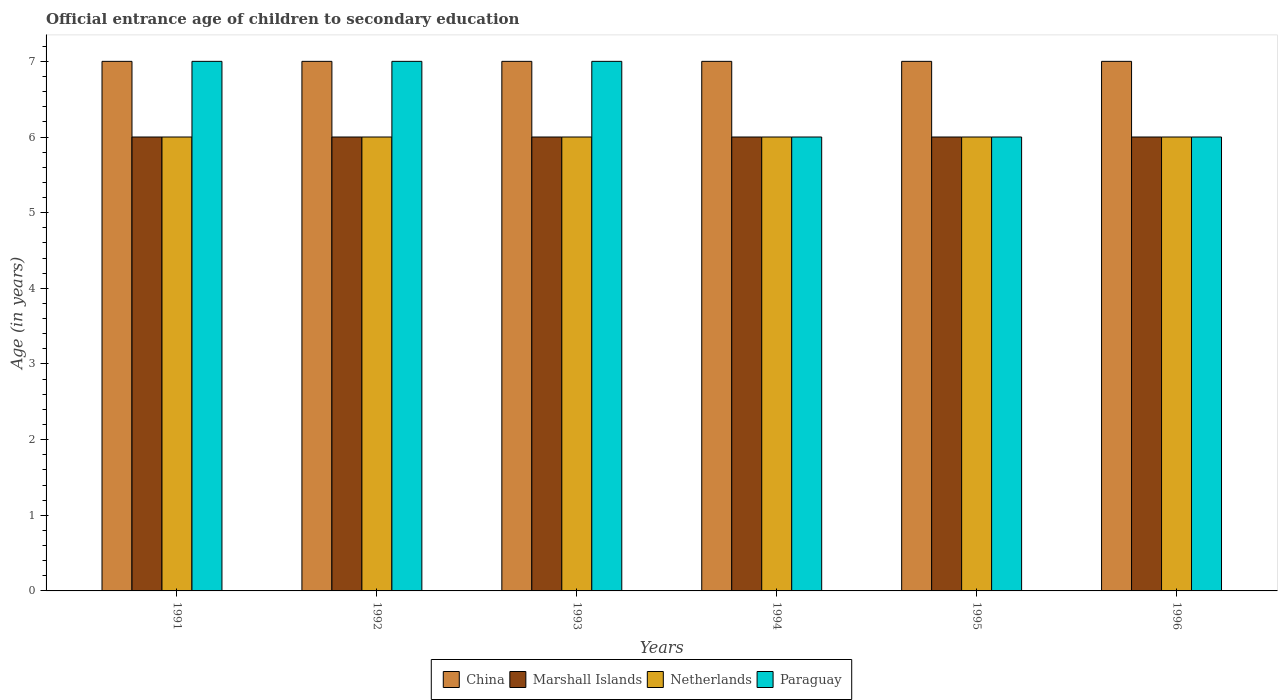How many bars are there on the 6th tick from the right?
Your answer should be compact. 4. What is the label of the 1st group of bars from the left?
Ensure brevity in your answer.  1991. In how many cases, is the number of bars for a given year not equal to the number of legend labels?
Ensure brevity in your answer.  0. What is the secondary school starting age of children in Paraguay in 1991?
Provide a short and direct response. 7. Across all years, what is the minimum secondary school starting age of children in Paraguay?
Provide a succinct answer. 6. In which year was the secondary school starting age of children in Marshall Islands maximum?
Your answer should be very brief. 1991. What is the total secondary school starting age of children in Netherlands in the graph?
Offer a terse response. 36. What is the difference between the secondary school starting age of children in Netherlands in 1991 and that in 1992?
Provide a succinct answer. 0. What is the difference between the secondary school starting age of children in Paraguay in 1993 and the secondary school starting age of children in Marshall Islands in 1994?
Ensure brevity in your answer.  1. In the year 1994, what is the difference between the secondary school starting age of children in Paraguay and secondary school starting age of children in Netherlands?
Make the answer very short. 0. What is the ratio of the secondary school starting age of children in China in 1992 to that in 1995?
Keep it short and to the point. 1. Is the difference between the secondary school starting age of children in Paraguay in 1995 and 1996 greater than the difference between the secondary school starting age of children in Netherlands in 1995 and 1996?
Your answer should be compact. No. What is the difference between the highest and the lowest secondary school starting age of children in Marshall Islands?
Give a very brief answer. 0. Is the sum of the secondary school starting age of children in Netherlands in 1993 and 1994 greater than the maximum secondary school starting age of children in China across all years?
Make the answer very short. Yes. Is it the case that in every year, the sum of the secondary school starting age of children in Netherlands and secondary school starting age of children in China is greater than the sum of secondary school starting age of children in Marshall Islands and secondary school starting age of children in Paraguay?
Keep it short and to the point. Yes. What does the 2nd bar from the left in 1991 represents?
Your response must be concise. Marshall Islands. How many years are there in the graph?
Keep it short and to the point. 6. Does the graph contain any zero values?
Make the answer very short. No. How are the legend labels stacked?
Your answer should be compact. Horizontal. What is the title of the graph?
Ensure brevity in your answer.  Official entrance age of children to secondary education. Does "Korea (Republic)" appear as one of the legend labels in the graph?
Provide a succinct answer. No. What is the label or title of the X-axis?
Keep it short and to the point. Years. What is the label or title of the Y-axis?
Your answer should be compact. Age (in years). What is the Age (in years) of China in 1991?
Your response must be concise. 7. What is the Age (in years) in Marshall Islands in 1991?
Your answer should be compact. 6. What is the Age (in years) in China in 1992?
Your response must be concise. 7. What is the Age (in years) in Paraguay in 1992?
Your answer should be compact. 7. What is the Age (in years) of China in 1993?
Provide a succinct answer. 7. What is the Age (in years) of Marshall Islands in 1993?
Give a very brief answer. 6. What is the Age (in years) in Paraguay in 1993?
Your answer should be compact. 7. What is the Age (in years) of Marshall Islands in 1994?
Provide a short and direct response. 6. What is the Age (in years) of Netherlands in 1994?
Keep it short and to the point. 6. What is the Age (in years) of Paraguay in 1994?
Your answer should be very brief. 6. What is the Age (in years) in Marshall Islands in 1995?
Your answer should be compact. 6. What is the Age (in years) of Netherlands in 1995?
Your response must be concise. 6. What is the Age (in years) in Paraguay in 1995?
Give a very brief answer. 6. What is the Age (in years) in China in 1996?
Make the answer very short. 7. What is the Age (in years) of Marshall Islands in 1996?
Your answer should be very brief. 6. What is the Age (in years) of Netherlands in 1996?
Ensure brevity in your answer.  6. What is the Age (in years) in Paraguay in 1996?
Ensure brevity in your answer.  6. Across all years, what is the maximum Age (in years) of Netherlands?
Your response must be concise. 6. Across all years, what is the minimum Age (in years) in China?
Make the answer very short. 7. Across all years, what is the minimum Age (in years) of Marshall Islands?
Your answer should be compact. 6. Across all years, what is the minimum Age (in years) of Netherlands?
Provide a succinct answer. 6. Across all years, what is the minimum Age (in years) of Paraguay?
Offer a terse response. 6. What is the total Age (in years) of China in the graph?
Your answer should be compact. 42. What is the total Age (in years) in Netherlands in the graph?
Ensure brevity in your answer.  36. What is the difference between the Age (in years) in China in 1991 and that in 1992?
Your answer should be very brief. 0. What is the difference between the Age (in years) in Marshall Islands in 1991 and that in 1992?
Your response must be concise. 0. What is the difference between the Age (in years) in Netherlands in 1991 and that in 1992?
Give a very brief answer. 0. What is the difference between the Age (in years) of Marshall Islands in 1991 and that in 1993?
Your answer should be compact. 0. What is the difference between the Age (in years) in Paraguay in 1991 and that in 1993?
Ensure brevity in your answer.  0. What is the difference between the Age (in years) in China in 1991 and that in 1994?
Keep it short and to the point. 0. What is the difference between the Age (in years) in China in 1991 and that in 1995?
Your response must be concise. 0. What is the difference between the Age (in years) in Marshall Islands in 1991 and that in 1995?
Offer a very short reply. 0. What is the difference between the Age (in years) in Netherlands in 1991 and that in 1995?
Provide a succinct answer. 0. What is the difference between the Age (in years) in Marshall Islands in 1991 and that in 1996?
Offer a terse response. 0. What is the difference between the Age (in years) of Paraguay in 1991 and that in 1996?
Give a very brief answer. 1. What is the difference between the Age (in years) in Marshall Islands in 1992 and that in 1993?
Keep it short and to the point. 0. What is the difference between the Age (in years) in China in 1992 and that in 1994?
Give a very brief answer. 0. What is the difference between the Age (in years) in Marshall Islands in 1992 and that in 1994?
Ensure brevity in your answer.  0. What is the difference between the Age (in years) in Netherlands in 1992 and that in 1994?
Your answer should be compact. 0. What is the difference between the Age (in years) in Paraguay in 1992 and that in 1995?
Your response must be concise. 1. What is the difference between the Age (in years) in Marshall Islands in 1992 and that in 1996?
Your answer should be compact. 0. What is the difference between the Age (in years) in Paraguay in 1992 and that in 1996?
Offer a very short reply. 1. What is the difference between the Age (in years) of China in 1993 and that in 1994?
Your answer should be compact. 0. What is the difference between the Age (in years) in Marshall Islands in 1993 and that in 1994?
Provide a short and direct response. 0. What is the difference between the Age (in years) of Netherlands in 1993 and that in 1994?
Your answer should be compact. 0. What is the difference between the Age (in years) of China in 1993 and that in 1995?
Provide a short and direct response. 0. What is the difference between the Age (in years) of Marshall Islands in 1993 and that in 1995?
Ensure brevity in your answer.  0. What is the difference between the Age (in years) in Netherlands in 1993 and that in 1995?
Offer a very short reply. 0. What is the difference between the Age (in years) in Marshall Islands in 1993 and that in 1996?
Give a very brief answer. 0. What is the difference between the Age (in years) in Netherlands in 1993 and that in 1996?
Your answer should be very brief. 0. What is the difference between the Age (in years) in Paraguay in 1993 and that in 1996?
Provide a short and direct response. 1. What is the difference between the Age (in years) in Paraguay in 1994 and that in 1995?
Keep it short and to the point. 0. What is the difference between the Age (in years) in China in 1994 and that in 1996?
Keep it short and to the point. 0. What is the difference between the Age (in years) of Marshall Islands in 1994 and that in 1996?
Keep it short and to the point. 0. What is the difference between the Age (in years) in China in 1995 and that in 1996?
Your response must be concise. 0. What is the difference between the Age (in years) of Netherlands in 1995 and that in 1996?
Your response must be concise. 0. What is the difference between the Age (in years) in Paraguay in 1995 and that in 1996?
Your response must be concise. 0. What is the difference between the Age (in years) of China in 1991 and the Age (in years) of Marshall Islands in 1992?
Make the answer very short. 1. What is the difference between the Age (in years) of China in 1991 and the Age (in years) of Netherlands in 1992?
Your answer should be very brief. 1. What is the difference between the Age (in years) in China in 1991 and the Age (in years) in Paraguay in 1992?
Give a very brief answer. 0. What is the difference between the Age (in years) in Marshall Islands in 1991 and the Age (in years) in Netherlands in 1992?
Make the answer very short. 0. What is the difference between the Age (in years) of Netherlands in 1991 and the Age (in years) of Paraguay in 1992?
Make the answer very short. -1. What is the difference between the Age (in years) in China in 1991 and the Age (in years) in Marshall Islands in 1993?
Make the answer very short. 1. What is the difference between the Age (in years) in China in 1991 and the Age (in years) in Paraguay in 1993?
Ensure brevity in your answer.  0. What is the difference between the Age (in years) in Marshall Islands in 1991 and the Age (in years) in Netherlands in 1993?
Your answer should be very brief. 0. What is the difference between the Age (in years) in Netherlands in 1991 and the Age (in years) in Paraguay in 1993?
Offer a very short reply. -1. What is the difference between the Age (in years) of Marshall Islands in 1991 and the Age (in years) of Netherlands in 1994?
Keep it short and to the point. 0. What is the difference between the Age (in years) in Netherlands in 1991 and the Age (in years) in Paraguay in 1994?
Offer a very short reply. 0. What is the difference between the Age (in years) in China in 1991 and the Age (in years) in Netherlands in 1995?
Your answer should be very brief. 1. What is the difference between the Age (in years) in Marshall Islands in 1991 and the Age (in years) in Netherlands in 1995?
Ensure brevity in your answer.  0. What is the difference between the Age (in years) in Netherlands in 1991 and the Age (in years) in Paraguay in 1995?
Make the answer very short. 0. What is the difference between the Age (in years) of China in 1991 and the Age (in years) of Netherlands in 1996?
Your answer should be very brief. 1. What is the difference between the Age (in years) of China in 1991 and the Age (in years) of Paraguay in 1996?
Your response must be concise. 1. What is the difference between the Age (in years) in Marshall Islands in 1991 and the Age (in years) in Netherlands in 1996?
Offer a very short reply. 0. What is the difference between the Age (in years) of Marshall Islands in 1991 and the Age (in years) of Paraguay in 1996?
Your response must be concise. 0. What is the difference between the Age (in years) in Netherlands in 1991 and the Age (in years) in Paraguay in 1996?
Offer a very short reply. 0. What is the difference between the Age (in years) of China in 1992 and the Age (in years) of Netherlands in 1993?
Offer a very short reply. 1. What is the difference between the Age (in years) in Marshall Islands in 1992 and the Age (in years) in Netherlands in 1993?
Your answer should be very brief. 0. What is the difference between the Age (in years) of Netherlands in 1992 and the Age (in years) of Paraguay in 1993?
Keep it short and to the point. -1. What is the difference between the Age (in years) in China in 1992 and the Age (in years) in Netherlands in 1994?
Ensure brevity in your answer.  1. What is the difference between the Age (in years) in China in 1992 and the Age (in years) in Paraguay in 1994?
Keep it short and to the point. 1. What is the difference between the Age (in years) of Marshall Islands in 1992 and the Age (in years) of Netherlands in 1994?
Make the answer very short. 0. What is the difference between the Age (in years) in Marshall Islands in 1992 and the Age (in years) in Paraguay in 1994?
Offer a terse response. 0. What is the difference between the Age (in years) in China in 1992 and the Age (in years) in Netherlands in 1995?
Offer a very short reply. 1. What is the difference between the Age (in years) in China in 1992 and the Age (in years) in Paraguay in 1995?
Your answer should be compact. 1. What is the difference between the Age (in years) in Marshall Islands in 1992 and the Age (in years) in Netherlands in 1995?
Ensure brevity in your answer.  0. What is the difference between the Age (in years) in Netherlands in 1992 and the Age (in years) in Paraguay in 1995?
Make the answer very short. 0. What is the difference between the Age (in years) in China in 1992 and the Age (in years) in Marshall Islands in 1996?
Provide a succinct answer. 1. What is the difference between the Age (in years) of China in 1992 and the Age (in years) of Netherlands in 1996?
Keep it short and to the point. 1. What is the difference between the Age (in years) of China in 1992 and the Age (in years) of Paraguay in 1996?
Your answer should be compact. 1. What is the difference between the Age (in years) in Marshall Islands in 1992 and the Age (in years) in Paraguay in 1996?
Your answer should be very brief. 0. What is the difference between the Age (in years) in China in 1993 and the Age (in years) in Marshall Islands in 1994?
Give a very brief answer. 1. What is the difference between the Age (in years) in China in 1993 and the Age (in years) in Netherlands in 1994?
Keep it short and to the point. 1. What is the difference between the Age (in years) of Marshall Islands in 1993 and the Age (in years) of Netherlands in 1994?
Offer a terse response. 0. What is the difference between the Age (in years) of China in 1993 and the Age (in years) of Netherlands in 1995?
Offer a terse response. 1. What is the difference between the Age (in years) in China in 1993 and the Age (in years) in Paraguay in 1995?
Your response must be concise. 1. What is the difference between the Age (in years) of Marshall Islands in 1993 and the Age (in years) of Netherlands in 1995?
Make the answer very short. 0. What is the difference between the Age (in years) in Marshall Islands in 1993 and the Age (in years) in Paraguay in 1995?
Offer a terse response. 0. What is the difference between the Age (in years) of Netherlands in 1993 and the Age (in years) of Paraguay in 1995?
Offer a terse response. 0. What is the difference between the Age (in years) in China in 1993 and the Age (in years) in Marshall Islands in 1996?
Your response must be concise. 1. What is the difference between the Age (in years) in Marshall Islands in 1993 and the Age (in years) in Netherlands in 1996?
Offer a very short reply. 0. What is the difference between the Age (in years) of Marshall Islands in 1993 and the Age (in years) of Paraguay in 1996?
Provide a short and direct response. 0. What is the difference between the Age (in years) of China in 1994 and the Age (in years) of Paraguay in 1995?
Keep it short and to the point. 1. What is the difference between the Age (in years) in Marshall Islands in 1994 and the Age (in years) in Netherlands in 1995?
Give a very brief answer. 0. What is the difference between the Age (in years) of Marshall Islands in 1994 and the Age (in years) of Paraguay in 1995?
Offer a terse response. 0. What is the difference between the Age (in years) in Netherlands in 1994 and the Age (in years) in Paraguay in 1995?
Offer a terse response. 0. What is the difference between the Age (in years) in China in 1994 and the Age (in years) in Paraguay in 1996?
Your answer should be compact. 1. What is the difference between the Age (in years) in Netherlands in 1994 and the Age (in years) in Paraguay in 1996?
Provide a succinct answer. 0. What is the difference between the Age (in years) of China in 1995 and the Age (in years) of Netherlands in 1996?
Offer a very short reply. 1. What is the difference between the Age (in years) of Marshall Islands in 1995 and the Age (in years) of Netherlands in 1996?
Provide a short and direct response. 0. What is the difference between the Age (in years) in Marshall Islands in 1995 and the Age (in years) in Paraguay in 1996?
Your answer should be very brief. 0. What is the average Age (in years) of China per year?
Your answer should be very brief. 7. What is the average Age (in years) in Paraguay per year?
Your answer should be very brief. 6.5. In the year 1991, what is the difference between the Age (in years) of China and Age (in years) of Marshall Islands?
Your answer should be compact. 1. In the year 1991, what is the difference between the Age (in years) of Marshall Islands and Age (in years) of Netherlands?
Your answer should be very brief. 0. In the year 1992, what is the difference between the Age (in years) in China and Age (in years) in Marshall Islands?
Your answer should be compact. 1. In the year 1992, what is the difference between the Age (in years) of Marshall Islands and Age (in years) of Paraguay?
Your response must be concise. -1. In the year 1992, what is the difference between the Age (in years) in Netherlands and Age (in years) in Paraguay?
Your answer should be compact. -1. In the year 1993, what is the difference between the Age (in years) of China and Age (in years) of Marshall Islands?
Give a very brief answer. 1. In the year 1993, what is the difference between the Age (in years) of China and Age (in years) of Paraguay?
Your answer should be very brief. 0. In the year 1993, what is the difference between the Age (in years) of Marshall Islands and Age (in years) of Paraguay?
Make the answer very short. -1. In the year 1994, what is the difference between the Age (in years) of China and Age (in years) of Netherlands?
Your response must be concise. 1. In the year 1994, what is the difference between the Age (in years) of Marshall Islands and Age (in years) of Paraguay?
Your answer should be very brief. 0. In the year 1994, what is the difference between the Age (in years) of Netherlands and Age (in years) of Paraguay?
Keep it short and to the point. 0. In the year 1995, what is the difference between the Age (in years) in China and Age (in years) in Marshall Islands?
Ensure brevity in your answer.  1. In the year 1995, what is the difference between the Age (in years) of China and Age (in years) of Paraguay?
Provide a succinct answer. 1. In the year 1995, what is the difference between the Age (in years) in Marshall Islands and Age (in years) in Netherlands?
Ensure brevity in your answer.  0. In the year 1995, what is the difference between the Age (in years) of Marshall Islands and Age (in years) of Paraguay?
Make the answer very short. 0. In the year 1995, what is the difference between the Age (in years) in Netherlands and Age (in years) in Paraguay?
Provide a short and direct response. 0. In the year 1996, what is the difference between the Age (in years) in China and Age (in years) in Paraguay?
Offer a terse response. 1. In the year 1996, what is the difference between the Age (in years) of Marshall Islands and Age (in years) of Netherlands?
Ensure brevity in your answer.  0. In the year 1996, what is the difference between the Age (in years) in Marshall Islands and Age (in years) in Paraguay?
Your answer should be very brief. 0. What is the ratio of the Age (in years) in Marshall Islands in 1991 to that in 1992?
Provide a succinct answer. 1. What is the ratio of the Age (in years) of Netherlands in 1991 to that in 1992?
Offer a terse response. 1. What is the ratio of the Age (in years) in Marshall Islands in 1991 to that in 1993?
Offer a terse response. 1. What is the ratio of the Age (in years) in Netherlands in 1991 to that in 1993?
Make the answer very short. 1. What is the ratio of the Age (in years) of China in 1991 to that in 1994?
Your response must be concise. 1. What is the ratio of the Age (in years) in Marshall Islands in 1991 to that in 1994?
Your answer should be very brief. 1. What is the ratio of the Age (in years) in Netherlands in 1991 to that in 1994?
Your answer should be very brief. 1. What is the ratio of the Age (in years) in Paraguay in 1991 to that in 1994?
Keep it short and to the point. 1.17. What is the ratio of the Age (in years) in China in 1991 to that in 1996?
Your answer should be compact. 1. What is the ratio of the Age (in years) of Marshall Islands in 1991 to that in 1996?
Provide a short and direct response. 1. What is the ratio of the Age (in years) in China in 1992 to that in 1993?
Provide a succinct answer. 1. What is the ratio of the Age (in years) in Marshall Islands in 1992 to that in 1994?
Your answer should be compact. 1. What is the ratio of the Age (in years) in Netherlands in 1992 to that in 1994?
Keep it short and to the point. 1. What is the ratio of the Age (in years) in Paraguay in 1992 to that in 1994?
Your answer should be compact. 1.17. What is the ratio of the Age (in years) of Netherlands in 1992 to that in 1995?
Keep it short and to the point. 1. What is the ratio of the Age (in years) of China in 1992 to that in 1996?
Keep it short and to the point. 1. What is the ratio of the Age (in years) in Netherlands in 1992 to that in 1996?
Ensure brevity in your answer.  1. What is the ratio of the Age (in years) in Paraguay in 1992 to that in 1996?
Your answer should be very brief. 1.17. What is the ratio of the Age (in years) of China in 1993 to that in 1994?
Your answer should be compact. 1. What is the ratio of the Age (in years) in Netherlands in 1993 to that in 1994?
Your answer should be compact. 1. What is the ratio of the Age (in years) in Netherlands in 1993 to that in 1995?
Offer a terse response. 1. What is the ratio of the Age (in years) in Marshall Islands in 1993 to that in 1996?
Your answer should be compact. 1. What is the ratio of the Age (in years) of China in 1994 to that in 1995?
Ensure brevity in your answer.  1. What is the ratio of the Age (in years) in Marshall Islands in 1994 to that in 1995?
Your answer should be compact. 1. What is the ratio of the Age (in years) of Marshall Islands in 1994 to that in 1996?
Make the answer very short. 1. What is the ratio of the Age (in years) of Netherlands in 1994 to that in 1996?
Your answer should be very brief. 1. What is the ratio of the Age (in years) in Paraguay in 1994 to that in 1996?
Ensure brevity in your answer.  1. What is the difference between the highest and the second highest Age (in years) in Marshall Islands?
Your answer should be compact. 0. What is the difference between the highest and the second highest Age (in years) in Netherlands?
Make the answer very short. 0. What is the difference between the highest and the lowest Age (in years) of China?
Your answer should be compact. 0. What is the difference between the highest and the lowest Age (in years) of Marshall Islands?
Give a very brief answer. 0. What is the difference between the highest and the lowest Age (in years) in Netherlands?
Offer a very short reply. 0. What is the difference between the highest and the lowest Age (in years) of Paraguay?
Keep it short and to the point. 1. 